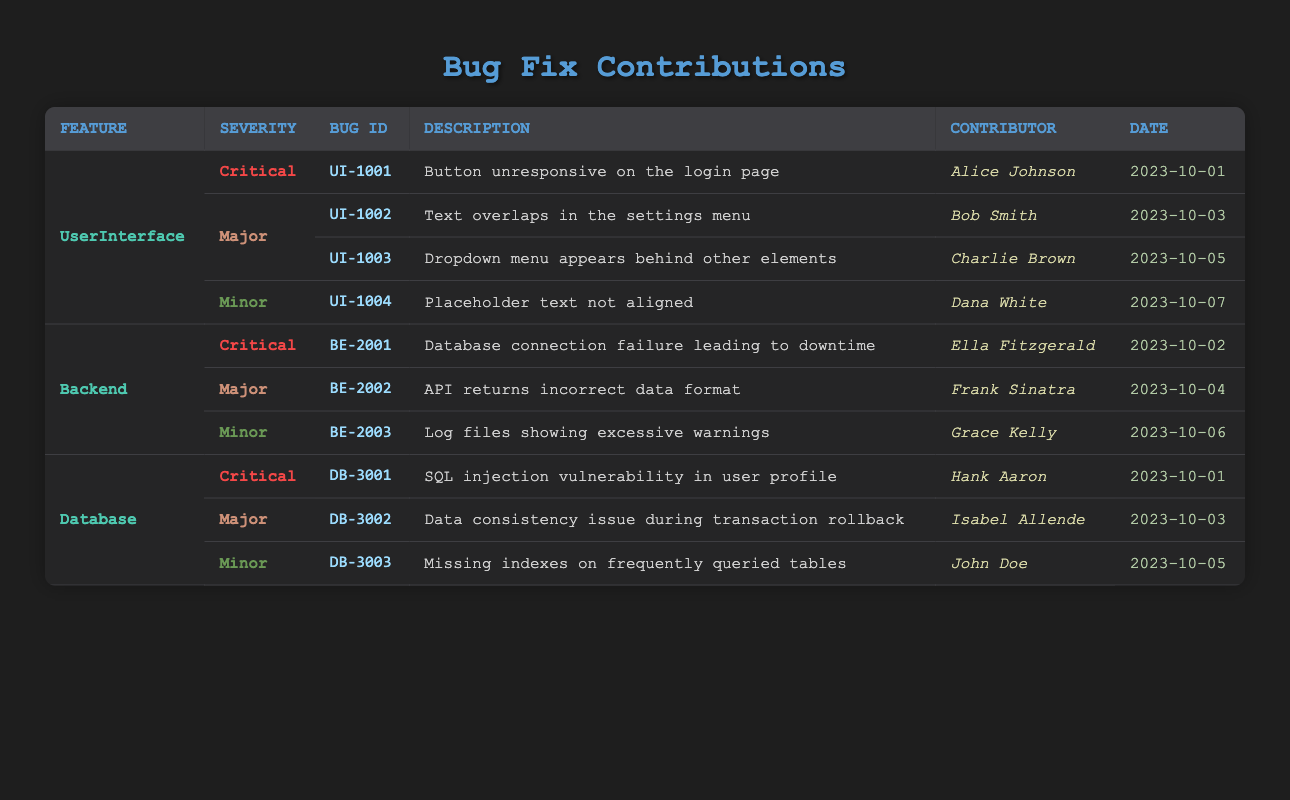What is the Bug ID for the critical bug in the User Interface? The critical bug in the User Interface is UI-1001, as indicated in the critical section for the UserInterface feature.
Answer: UI-1001 Who contributed to fixing the minor bug in the Database? The minor bug in the Database is identified as DB-3003, which was contributed by John Doe according to the table.
Answer: John Doe How many major bugs were fixed in the User Interface? There are two major bugs listed under the UserInterface feature, which are UI-1002 and UI-1003. Therefore, the count of major bugs is two.
Answer: 2 Which feature has the most critical bug contributions? Both User Interface and Database have one critical bug each (UI-1001 and DB-3001), while the Backend also has one critical bug (BE-2001). Thus, they are tied as they all have the same count of critical bug contributions.
Answer: All features are tied Is there a major bug fix reported on October 4th? Yes, there is a major bug fix reported on October 4th, which is BE-2002 concerning the Backend feature.
Answer: Yes What is the total number of bugs categorized as minor across all features? The total number of minor bugs includes UI-1004, BE-2003, and DB-3003, which sums up to three minor bugs in total, one for each feature.
Answer: 3 Which contributor fixed the database's critical bug? The critical bug in the Database, which is DB-3001, was fixed by Hank Aaron as per the information in the table.
Answer: Hank Aaron What is the difference in the number of critical bugs between Backend and User Interface? Both the Backend and the User Interface have one critical bug each, so the difference in the number is zero.
Answer: 0 What is the latest bug fix date listed in the table? The latest date listed for any bug fix is October 7, 2023, when Dana White fixed the minor bug UI-1004 in the User Interface feature.
Answer: October 7, 2023 